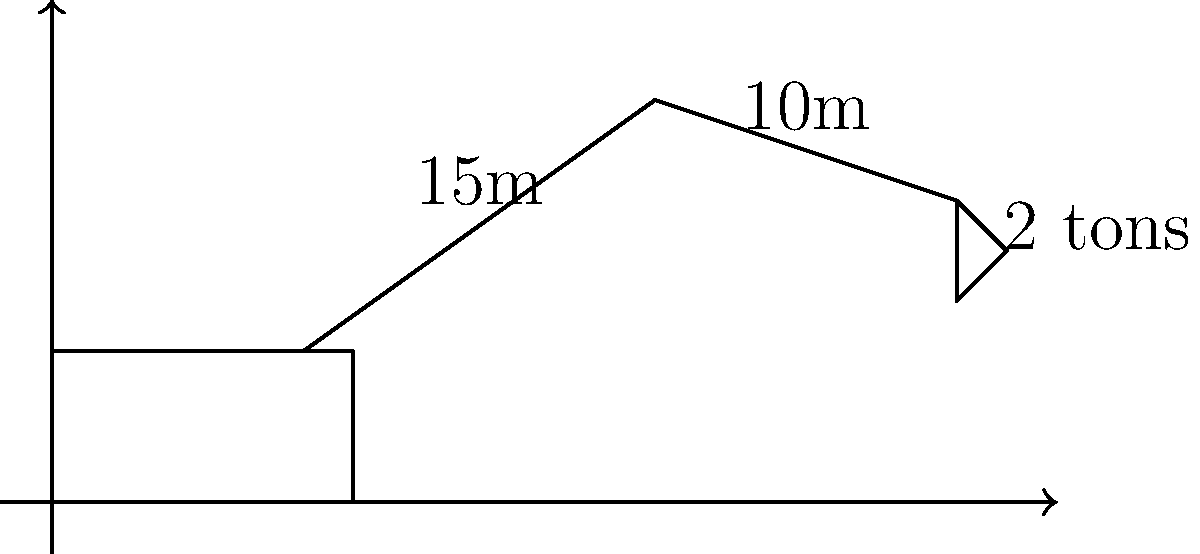As a businessman renting heavy equipment, you need to determine the optimal loading capacity of an excavator. The excavator has a boom length of 15m and an arm length of 10m. The bucket at the end of the arm can hold 2 tons. Assuming the excavator's stability decreases linearly with the horizontal distance of the load from the base, and the maximum capacity at the base is 20 tons, calculate the maximum safe load capacity when the bucket is fully extended horizontally. Round your answer to the nearest tenth of a ton. To solve this problem, we'll follow these steps:

1) First, calculate the total horizontal reach of the excavator:
   Horizontal reach = Boom length + Arm length
   $15m + 10m = 25m$

2) Set up a linear equation for the load capacity:
   Let $y$ be the load capacity and $x$ be the horizontal distance.
   $y = mx + b$, where $m$ is the slope and $b$ is the y-intercept.

3) We know two points on this line:
   At $x = 0$, $y = 20$ tons (maximum capacity at the base)
   At $x = 25$, we need to find $y$

4) Calculate the slope:
   $m = \frac{y_2 - y_1}{x_2 - x_1} = \frac{y - 20}{25 - 0} = \frac{y - 20}{25}$

5) Use the point-slope form of a line:
   $y - y_1 = m(x - x_1)$
   $y - 20 = \frac{y - 20}{25}(x - 0)$

6) Simplify:
   $y - 20 = \frac{y - 20}{25}x$
   $25(y - 20) = (y - 20)x$
   $25y - 500 = xy - 20x$

7) Solve for $y$ when $x = 25$:
   $25y - 500 = 25y - 500$
   $0 = 0$

   This means our equation is correct.

8) Substitute $x = 25$ into our original equation:
   $y - 20 = \frac{y - 20}{25}(25)$
   $y - 20 = y - 20$
   $y = 20$

9) The maximum safe load at full extension is 20 tons. However, we need to subtract the weight of the bucket:
   $20 - 2 = 18$ tons

Therefore, the maximum safe load capacity when the bucket is fully extended horizontally is 18 tons.
Answer: 18.0 tons 